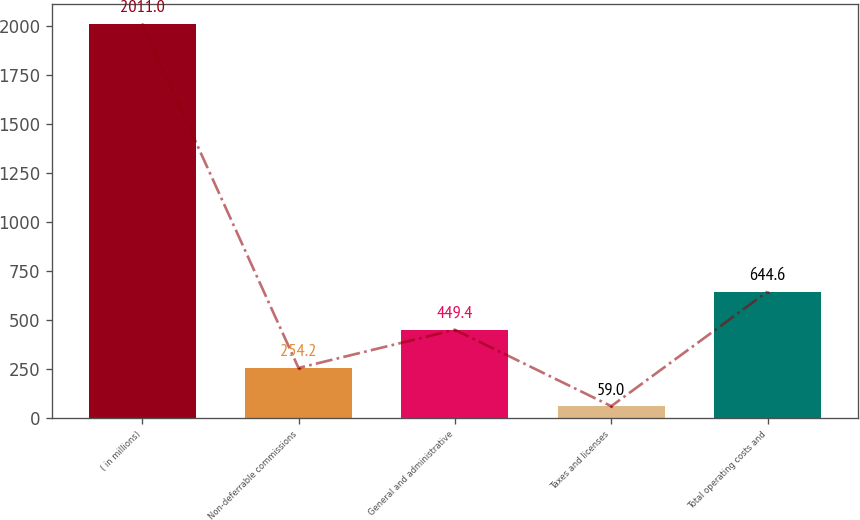Convert chart to OTSL. <chart><loc_0><loc_0><loc_500><loc_500><bar_chart><fcel>( in millions)<fcel>Non-deferrable commissions<fcel>General and administrative<fcel>Taxes and licenses<fcel>Total operating costs and<nl><fcel>2011<fcel>254.2<fcel>449.4<fcel>59<fcel>644.6<nl></chart> 